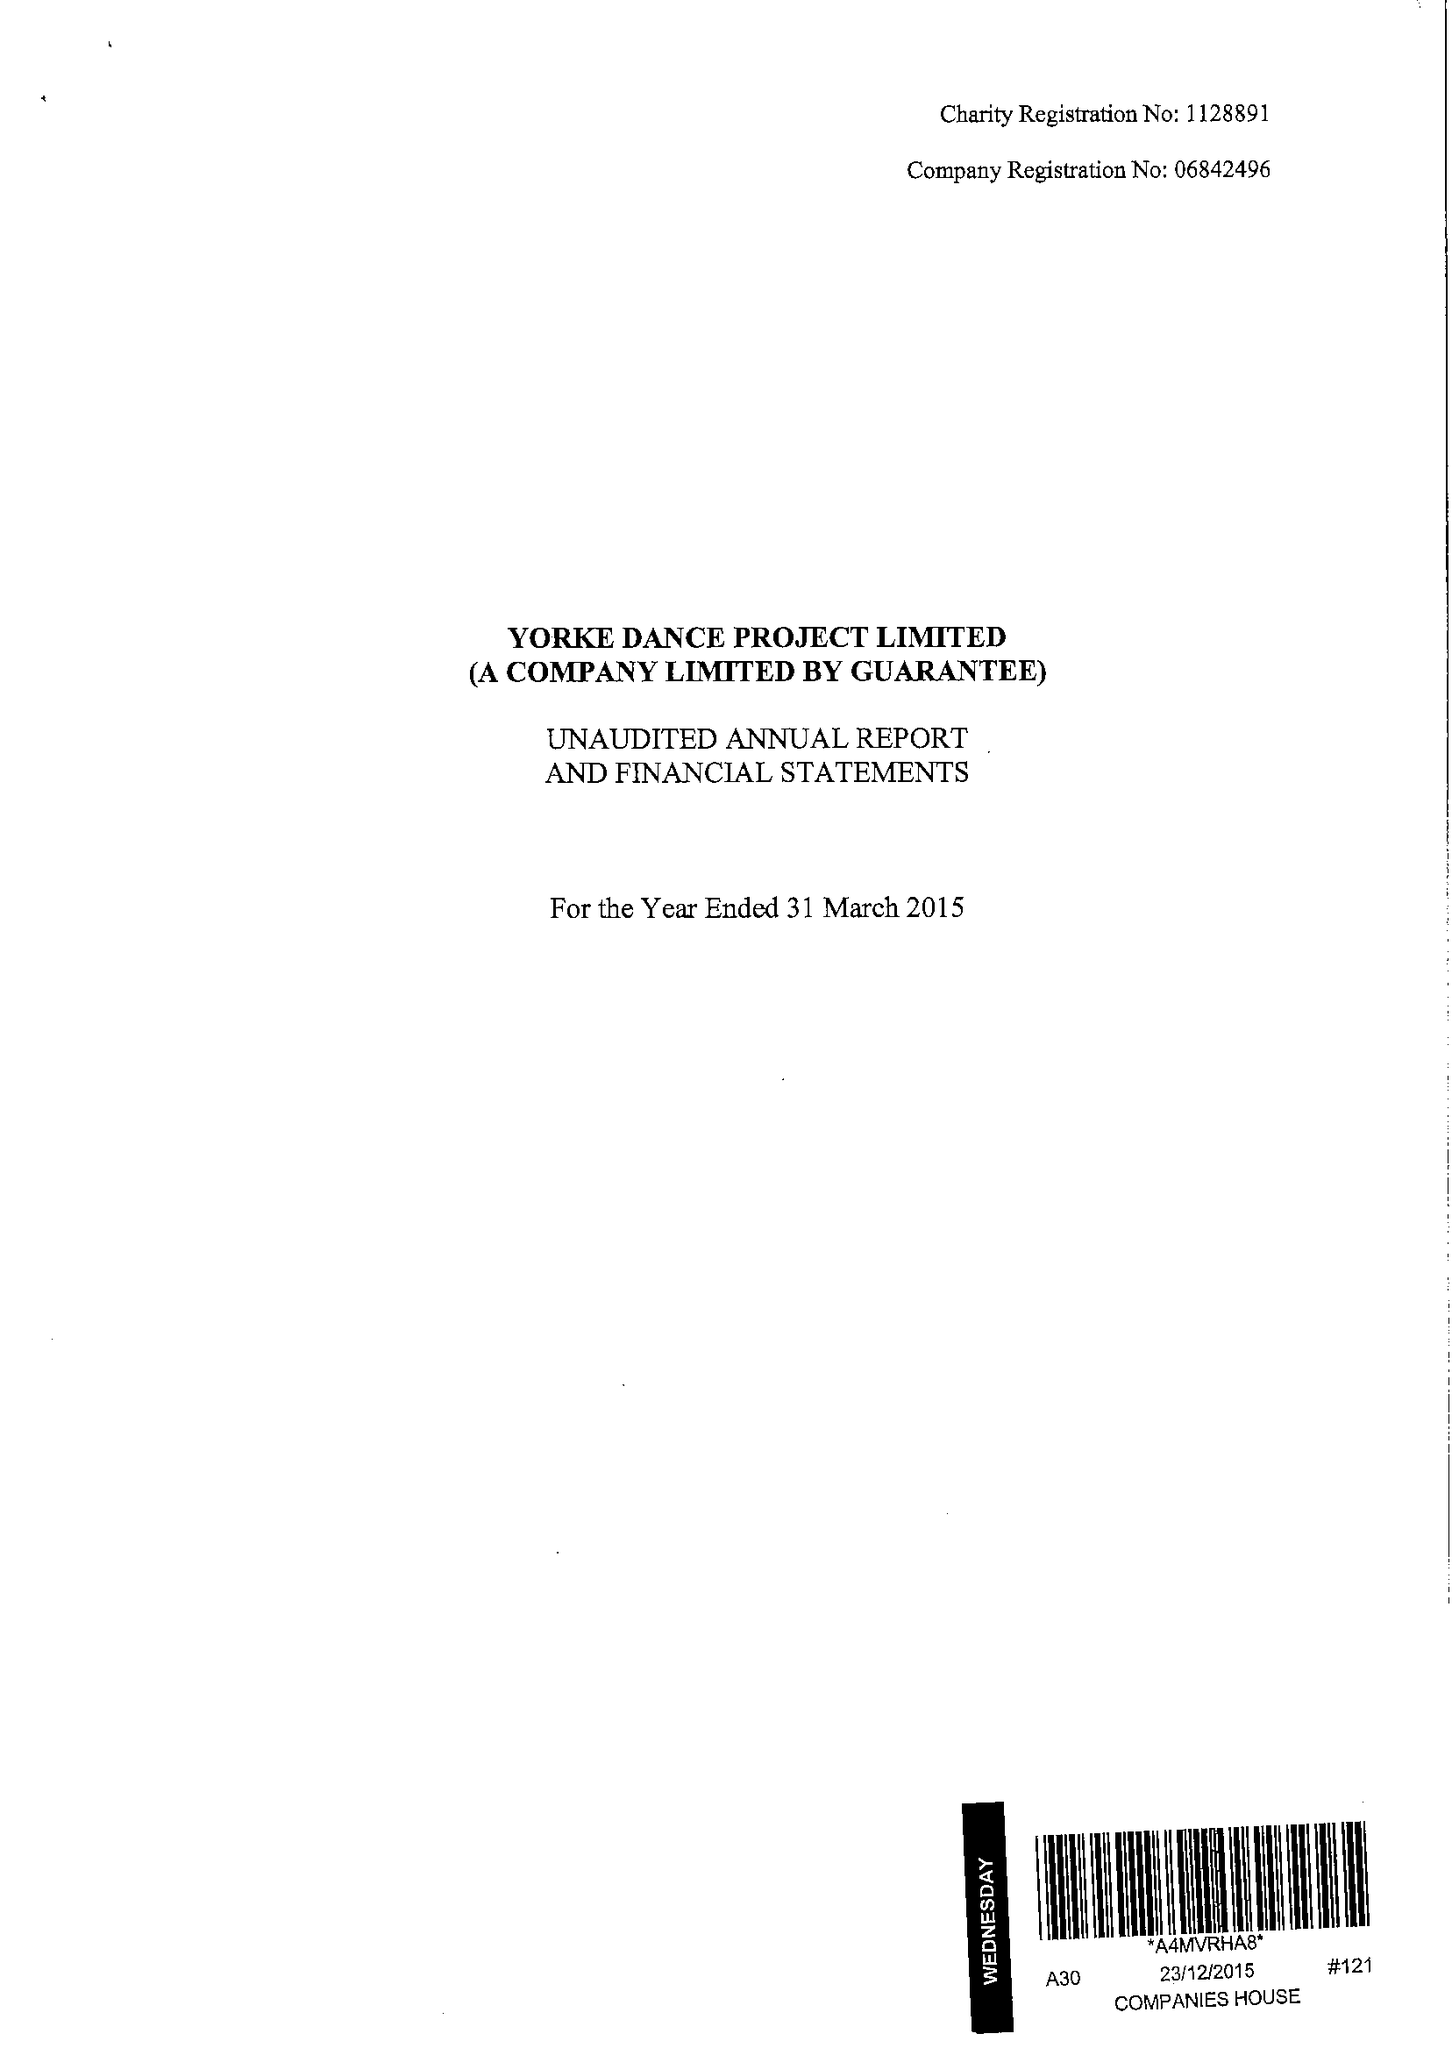What is the value for the address__post_town?
Answer the question using a single word or phrase. LONDON 